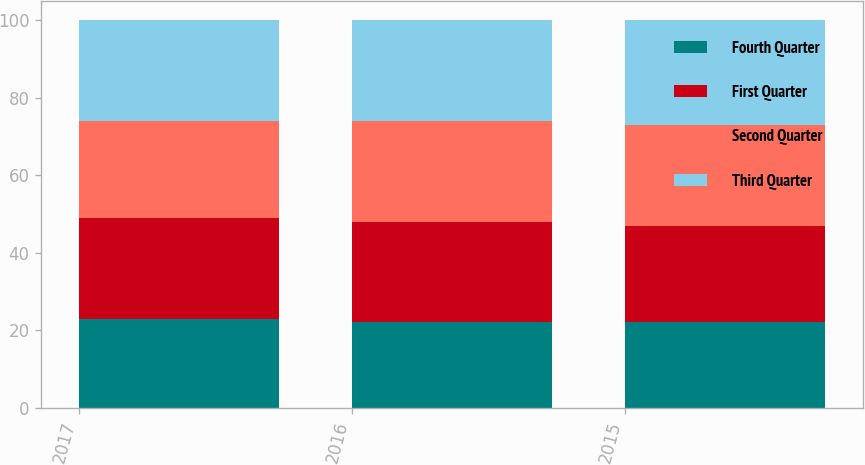<chart> <loc_0><loc_0><loc_500><loc_500><stacked_bar_chart><ecel><fcel>2017<fcel>2016<fcel>2015<nl><fcel>Fourth Quarter<fcel>23<fcel>22<fcel>22<nl><fcel>First Quarter<fcel>26<fcel>26<fcel>25<nl><fcel>Second Quarter<fcel>25<fcel>26<fcel>26<nl><fcel>Third Quarter<fcel>26<fcel>26<fcel>27<nl></chart> 